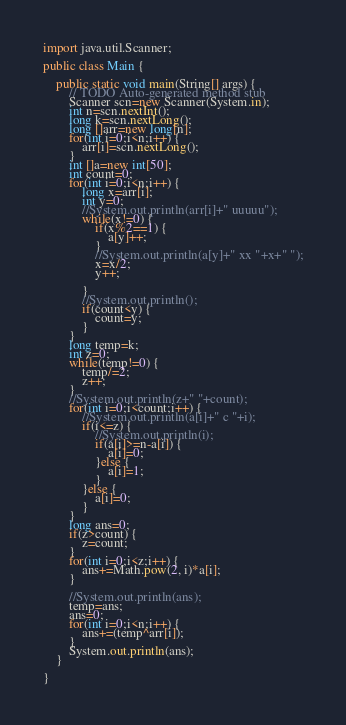<code> <loc_0><loc_0><loc_500><loc_500><_Java_>
import java.util.Scanner;

public class Main {

	public static void main(String[] args) {
		// TODO Auto-generated method stub
		Scanner scn=new Scanner(System.in);
		int n=scn.nextInt();
		long k=scn.nextLong();
		long []arr=new long[n];
		for(int i=0;i<n;i++) {
			arr[i]=scn.nextLong();
		}
		int []a=new int[50];
		int count=0;
		for(int i=0;i<n;i++) {
			long x=arr[i];
			int y=0;
			//System.out.println(arr[i]+" uuuuu");
			while(x!=0) {
				if(x%2==1) {
					a[y]++;
				}
				//System.out.println(a[y]+" xx "+x+" ");
				x=x/2;
				y++;
				
			}
			//System.out.println();
			if(count<y) {
				count=y;
			}
		}
		long temp=k;
		int z=0;
		while(temp!=0) {
			temp/=2;
			z++;
		}
		//System.out.println(z+" "+count);
		for(int i=0;i<count;i++) {
			//System.out.println(a[i]+" c "+i);
			if(i<=z) {
				//System.out.println(i);
				if(a[i]>=n-a[i]) {
					a[i]=0;
				}else {
					a[i]=1;
				}
			}else {
				a[i]=0;
			}
		}
		long ans=0;
		if(z>count) {
			z=count;
		}
		for(int i=0;i<z;i++) {
			ans+=Math.pow(2, i)*a[i];
		}
		
		//System.out.println(ans);
		temp=ans;
		ans=0;
		for(int i=0;i<n;i++) {
			ans+=(temp^arr[i]);
		}
		System.out.println(ans);
	}

}
</code> 